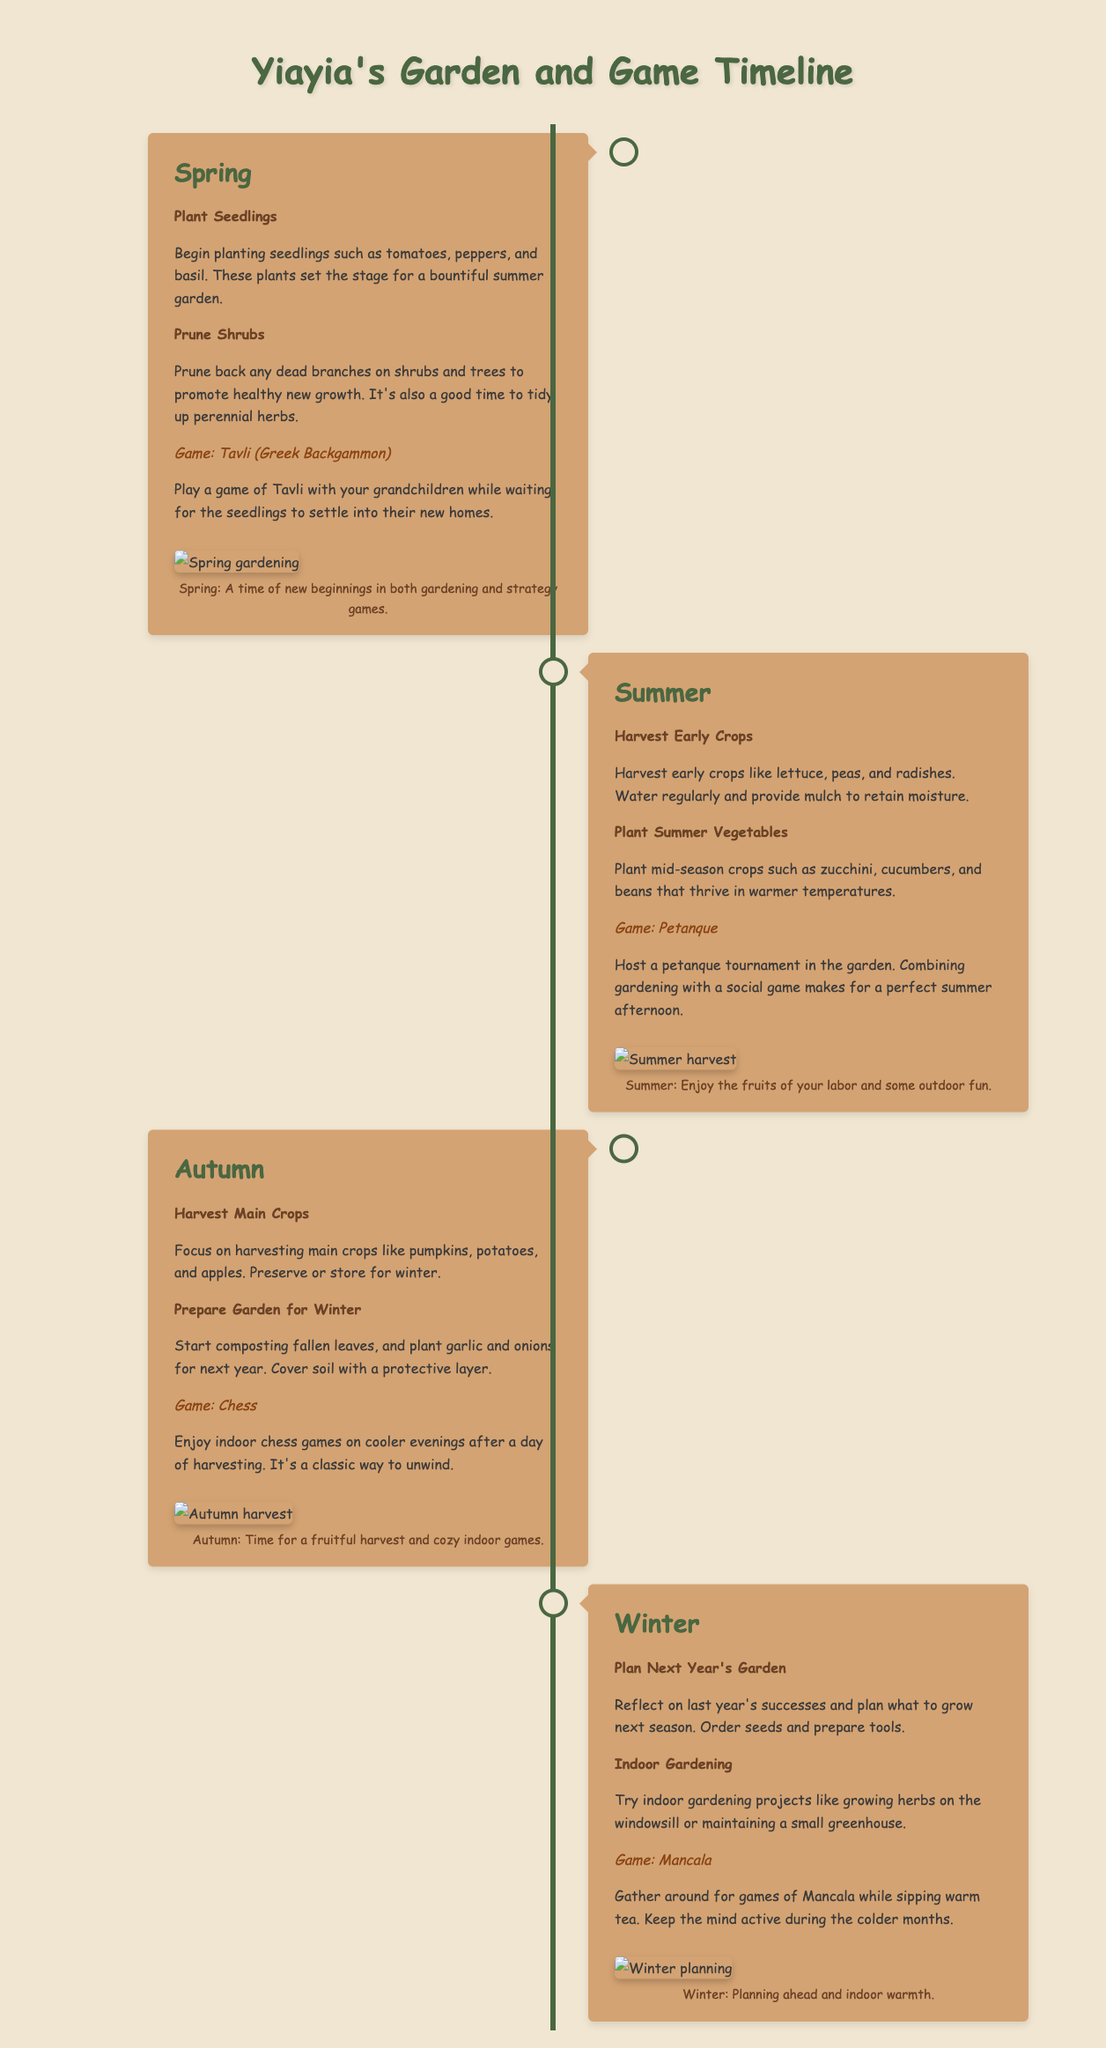What activities are suggested for Spring? The activities suggested for Spring are planting seedlings and pruning shrubs.
Answer: Plant Seedlings, Prune Shrubs Which game is associated with Summer? The game associated with Summer is Petanque.
Answer: Petanque What is the main focus of Autumn gardening activities? The main focus of Autumn gardening activities is harvesting main crops.
Answer: Harvest Main Crops What gardening activity is recommended for Winter? The recommended gardening activity for Winter is planning next year's garden.
Answer: Plan Next Year's Garden How many seasonal sections are there in the timeline? The timeline contains four seasonal sections: Spring, Summer, Autumn, and Winter.
Answer: Four What is the caption for the Winter section? The caption for the Winter section emphasizes planning and indoor warmth.
Answer: Planning ahead and indoor warmth Which crop is mentioned for Autumn harvesting? The crop mentioned for Autumn harvesting is pumpkins.
Answer: Pumpkins What should be done to the garden for Winter preparation? Composting fallen leaves is suggested for Winter garden preparation.
Answer: Composting fallen leaves What type of game is played during Spring? The game played during Spring is Tavli.
Answer: Tavli 